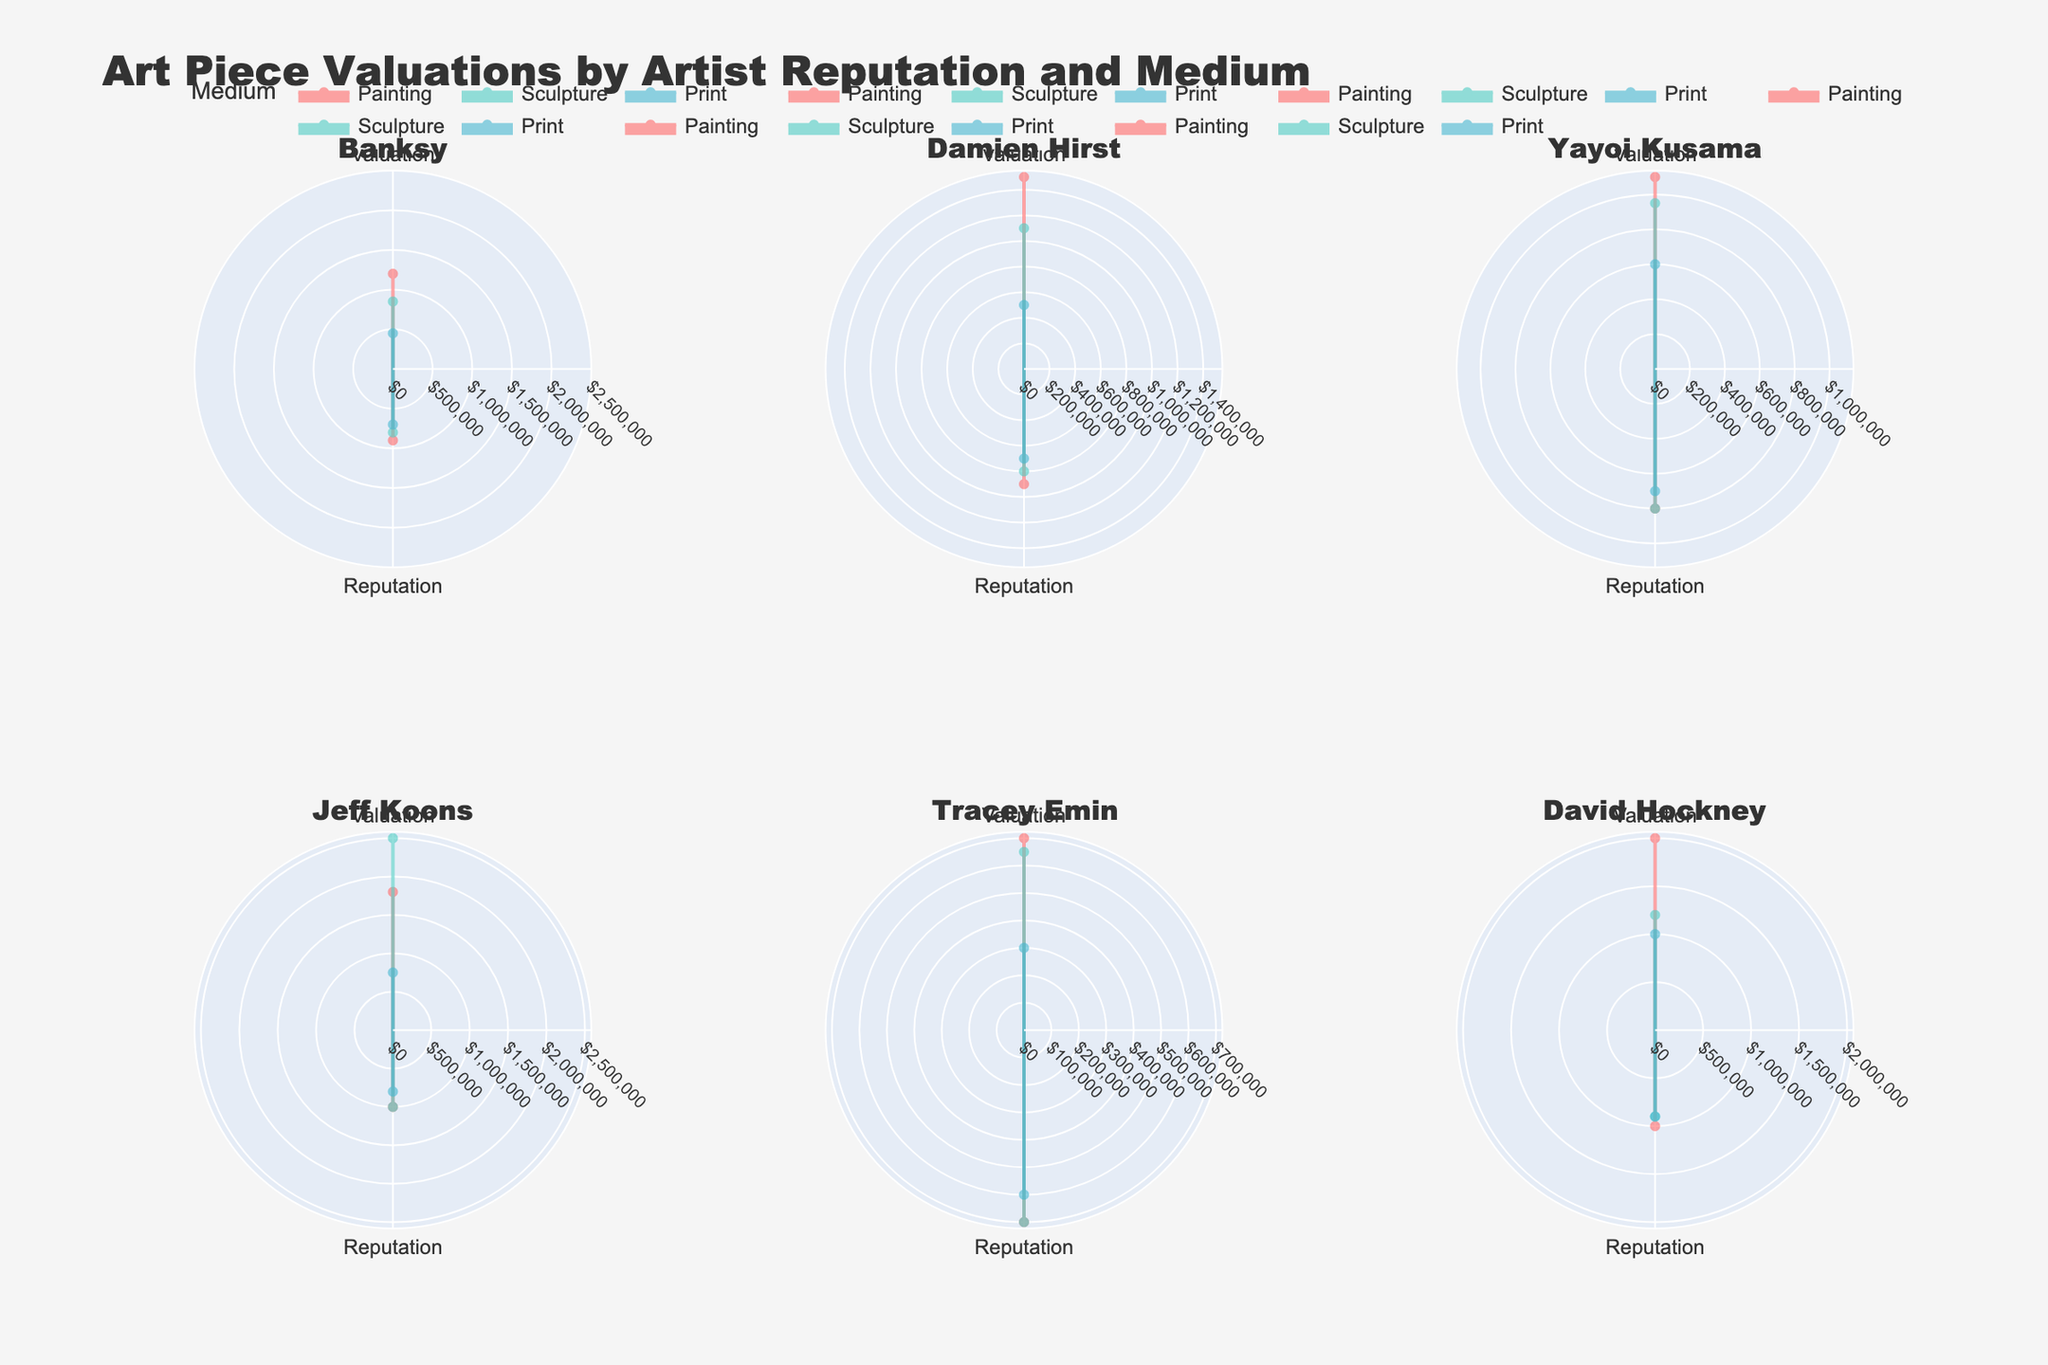What are the mediums represented for Banksy's art? The mediums for each artist are shown in each subplot. For Banksy, three distinct traces with different colors correspond to different mediums: Painting, Sculpture, and Print.
Answer: Painting, Sculpture, Print How does Tracey Emin's reputation compare to her art valuations? Tracey Emin's subplot shows two points: Valuation and Reputation. Reputation points are scaled, and you can compare their relative lengths and shapes. Her highest valuation is $700,000 while her reputation is a bit longer, indicating a higher proportionate number than the valuation point.
Answer: Her reputation is higher relative to her art valuations Which artist has the highest valuation for sculptures? By examining the subplots and looking at the radial lengths for sculpture, Jeff Koons stands out in his subplot with the longest radial length for Sculpture, reaching $2,500,000.
Answer: Jeff Koons What is the average valuation and reputation for Yayoi Kusama's artworks? To find this, average the valuations and reputations displayed for Yayoi Kusama. Valuations are $1,100,000, $950,000, and $600,000, and reputations are 8 each. So, (1,100,000 + 950,000 + 600,000) / 3 = $883,333.33, and average reputation = 8.
Answer: $883,333.33, 8 Compare the valuations of paintings between Damien Hirst and David Hockney. Look at the subplots for each artist and compare the radial lengths for Painting. Damien Hirst's painting valuation reaches $1,500,000, whereas David Hockney's reaches $2,000,000.
Answer: David Hockney's painting valuation is higher than Damien Hirst's Which artist has the highest reputation for their print medium? Examining the subplots, the reputation points for Print are scaled similarly. Jeff Koons has the highest radial length for Print with a reputation of 8, followed by David Hockney with a 9.
Answer: David Hockney How does the valuation of Banksy's paintings compare to his prints? In Banksy's subplot, compare the radial lengths for Painting ($1,200,000) and Print ($450,000). The valuation for Paintings is significantly higher.
Answer: Paintings have a higher valuation What is the total valuation of all Jeff Koons' artworks combined? For each of Jeff Koons' art mediums, sum the valuations: ($1,800,000 for Painting) + ($2,500,000 for Sculpture) + ($750,000 for Print) = $5,050,000.
Answer: $5,050,000 What can you infer about the relationship between the artist's reputation and the valuation of their sculptures? By comparing the subplots for sculptures, we see that the artists with higher reputations (Jeff Koons, David Hockney) also tend to have higher valuations, suggesting a positive correlation between reputation and sculpture valuation.
Answer: Higher reputation correlates with higher sculpture valuation 